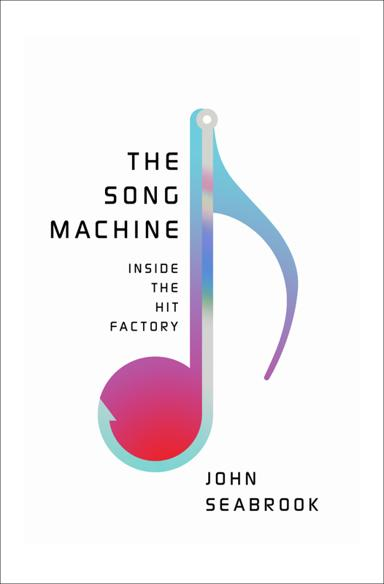What is the title and author of the book mentioned in the image? The book depicted in the image is titled 'The Song Machine: Inside the Hit Factory,' authored by John Seabrook. The cover features a stylized musical note, indicating its thematic focus on the music industry. 